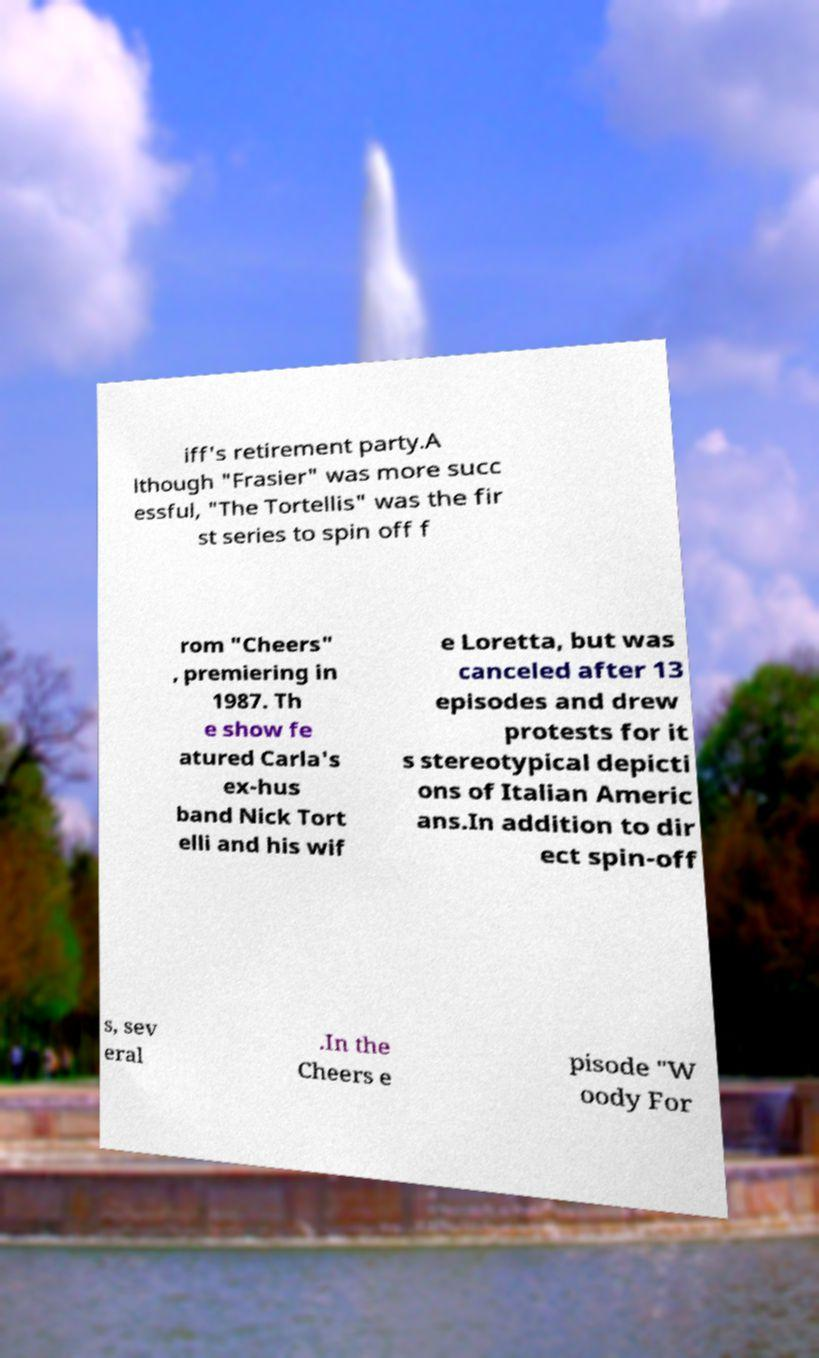For documentation purposes, I need the text within this image transcribed. Could you provide that? iff's retirement party.A lthough "Frasier" was more succ essful, "The Tortellis" was the fir st series to spin off f rom "Cheers" , premiering in 1987. Th e show fe atured Carla's ex-hus band Nick Tort elli and his wif e Loretta, but was canceled after 13 episodes and drew protests for it s stereotypical depicti ons of Italian Americ ans.In addition to dir ect spin-off s, sev eral .In the Cheers e pisode "W oody For 